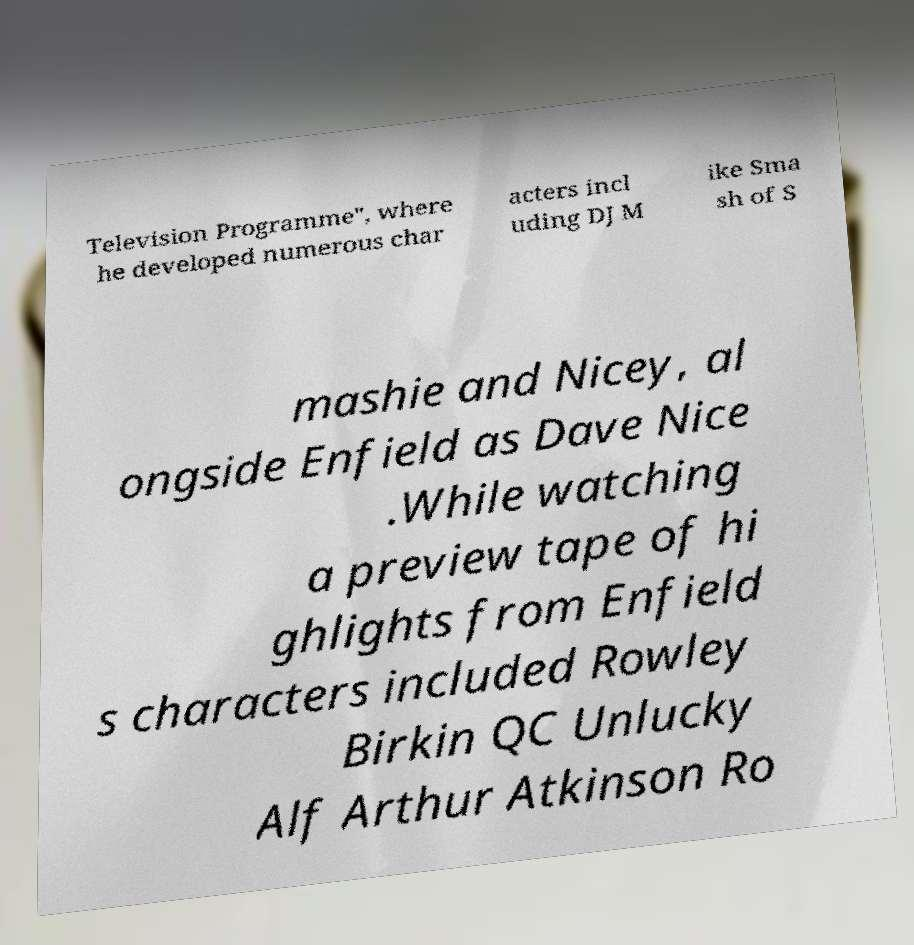Could you assist in decoding the text presented in this image and type it out clearly? Television Programme", where he developed numerous char acters incl uding DJ M ike Sma sh of S mashie and Nicey, al ongside Enfield as Dave Nice .While watching a preview tape of hi ghlights from Enfield s characters included Rowley Birkin QC Unlucky Alf Arthur Atkinson Ro 